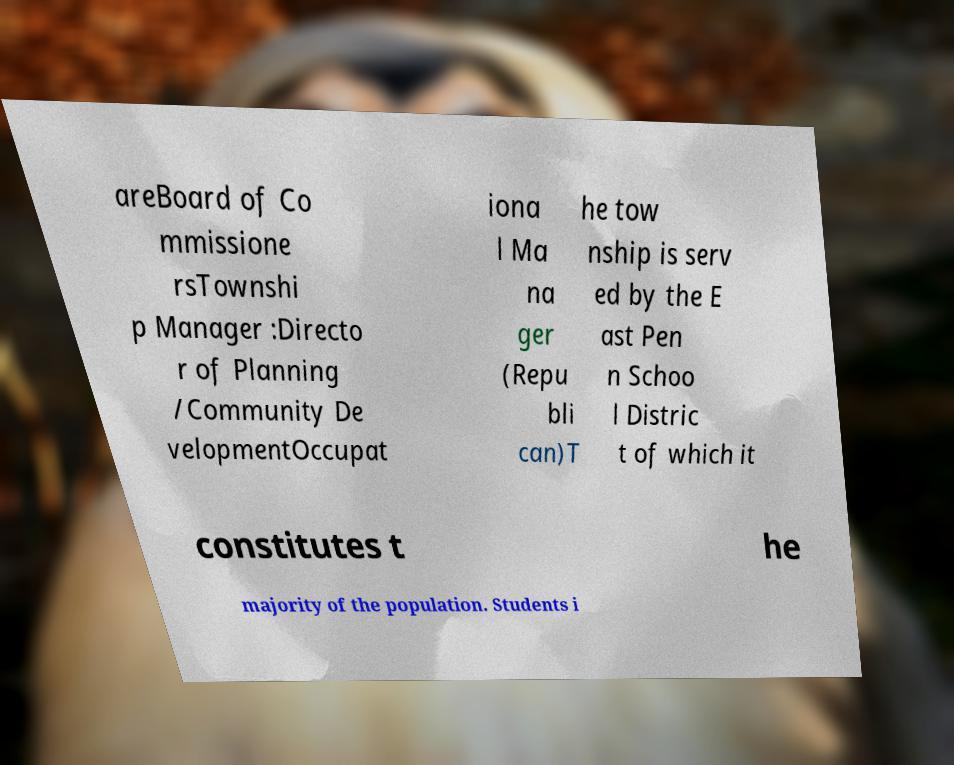What messages or text are displayed in this image? I need them in a readable, typed format. areBoard of Co mmissione rsTownshi p Manager :Directo r of Planning /Community De velopmentOccupat iona l Ma na ger (Repu bli can)T he tow nship is serv ed by the E ast Pen n Schoo l Distric t of which it constitutes t he majority of the population. Students i 